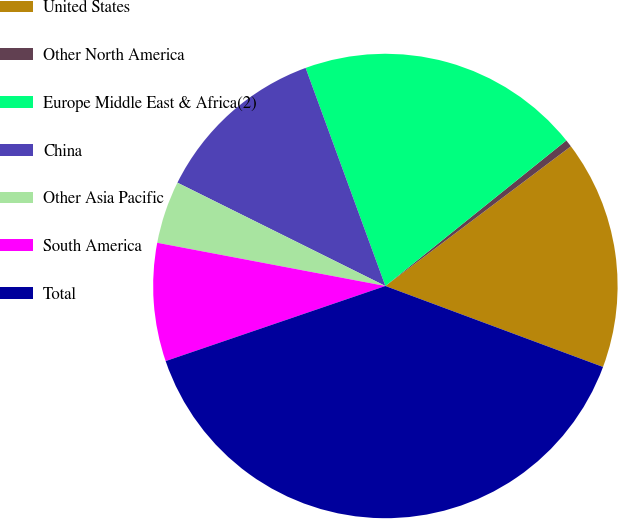Convert chart to OTSL. <chart><loc_0><loc_0><loc_500><loc_500><pie_chart><fcel>United States<fcel>Other North America<fcel>Europe Middle East & Africa(2)<fcel>China<fcel>Other Asia Pacific<fcel>South America<fcel>Total<nl><fcel>15.94%<fcel>0.51%<fcel>19.8%<fcel>12.08%<fcel>4.36%<fcel>8.22%<fcel>39.09%<nl></chart> 